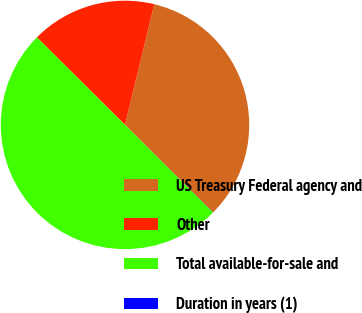Convert chart. <chart><loc_0><loc_0><loc_500><loc_500><pie_chart><fcel>US Treasury Federal agency and<fcel>Other<fcel>Total available-for-sale and<fcel>Duration in years (1)<nl><fcel>33.65%<fcel>16.34%<fcel>49.99%<fcel>0.02%<nl></chart> 